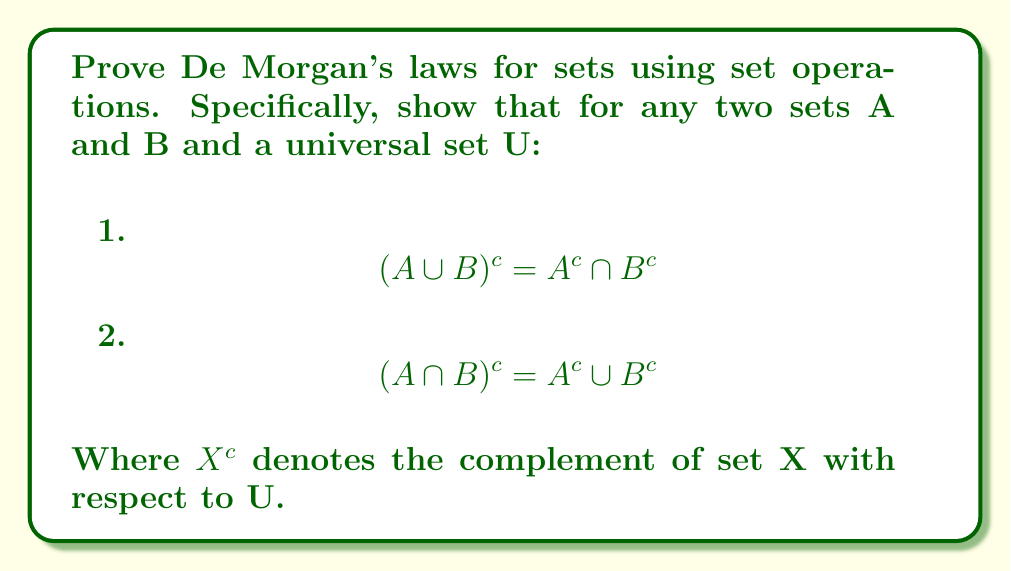Can you answer this question? To prove De Morgan's laws for sets, we need to show that the left-hand side (LHS) and right-hand side (RHS) of each equation are equal. We can do this by proving that each side is a subset of the other.

1. Proving $$(A \cup B)^c = A^c \cap B^c$$

Step 1: Show that $(A \cup B)^c \subseteq A^c \cap B^c$
Let $x \in (A \cup B)^c$. This means $x \notin (A \cup B)$.
Therefore, $x \notin A$ and $x \notin B$.
This implies $x \in A^c$ and $x \in B^c$.
Hence, $x \in A^c \cap B^c$.

Step 2: Show that $A^c \cap B^c \subseteq (A \cup B)^c$
Let $x \in A^c \cap B^c$. This means $x \in A^c$ and $x \in B^c$.
Therefore, $x \notin A$ and $x \notin B$.
This implies $x \notin (A \cup B)$.
Hence, $x \in (A \cup B)^c$.

Since both inclusions hold, we have $(A \cup B)^c = A^c \cap B^c$.

2. Proving $$(A \cap B)^c = A^c \cup B^c$$

Step 1: Show that $(A \cap B)^c \subseteq A^c \cup B^c$
Let $x \in (A \cap B)^c$. This means $x \notin (A \cap B)$.
Therefore, $x \notin A$ or $x \notin B$ (or both).
This implies $x \in A^c$ or $x \in B^c$ (or both).
Hence, $x \in A^c \cup B^c$.

Step 2: Show that $A^c \cup B^c \subseteq (A \cap B)^c$
Let $x \in A^c \cup B^c$. This means $x \in A^c$ or $x \in B^c$ (or both).
Therefore, $x \notin A$ or $x \notin B$ (or both).
This implies $x \notin (A \cap B)$.
Hence, $x \in (A \cap B)^c$.

Since both inclusions hold, we have $(A \cap B)^c = A^c \cup B^c$.
Answer: De Morgan's laws for sets are valid:

1. $$(A \cup B)^c = A^c \cap B^c$$
2. $$(A \cap B)^c = A^c \cup B^c$$

These equalities hold for any sets A and B within a universal set U. 